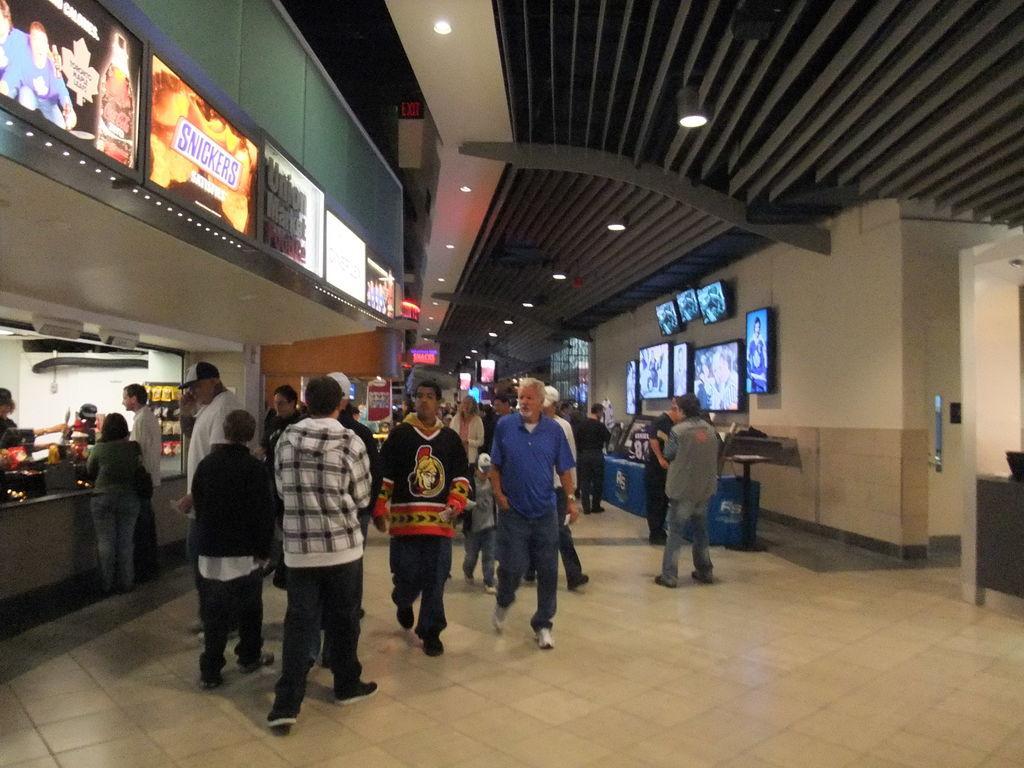In one or two sentences, can you explain what this image depicts? In this image we can see an inside view of a building in which group of people is standing on the floor. On the left side of the image we can see group of sign boards with some text. On the right side, we can see a group of televisions on the wall. In the background, we can see some lights and a door 